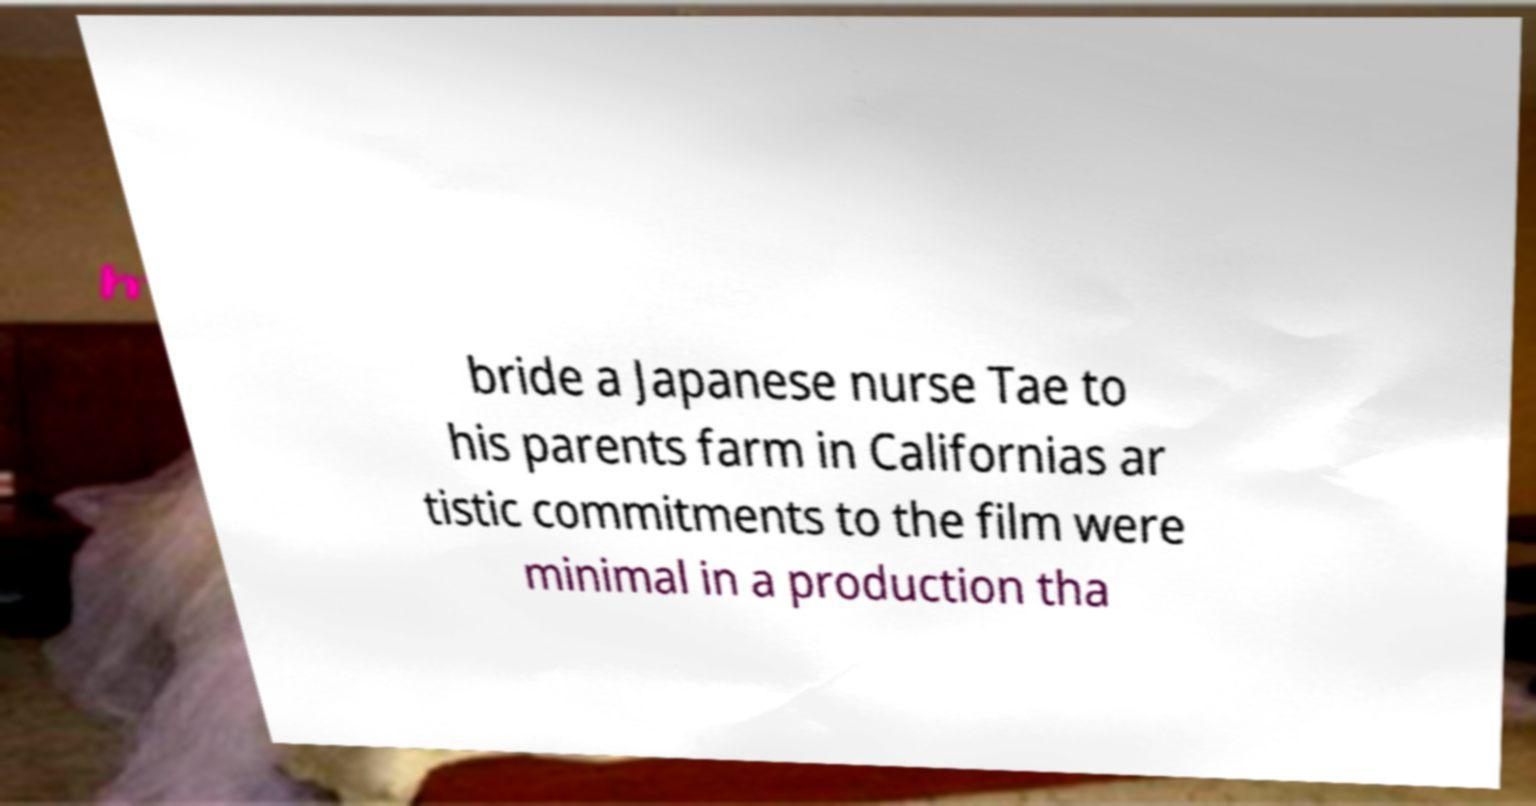Can you read and provide the text displayed in the image?This photo seems to have some interesting text. Can you extract and type it out for me? bride a Japanese nurse Tae to his parents farm in Californias ar tistic commitments to the film were minimal in a production tha 